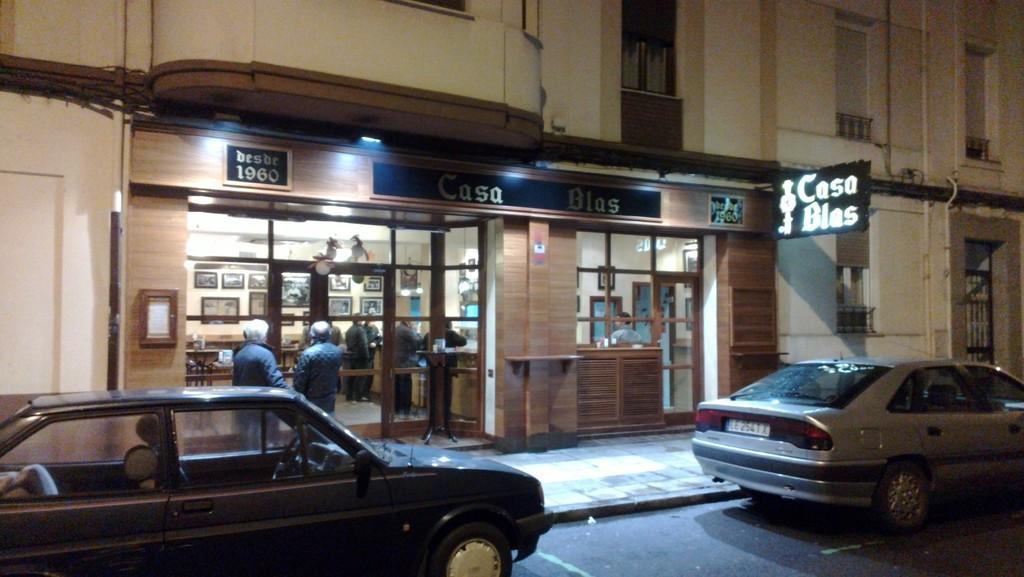Can you describe this image briefly? There are two cars on the road. Here we can see a building, boards, windows, glasses, door, and few persons. There are frames on the wall. 